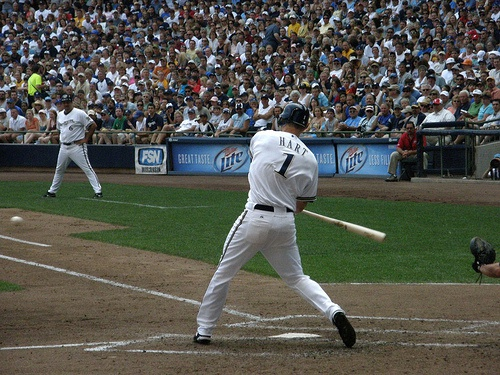Describe the objects in this image and their specific colors. I can see people in gray, black, maroon, and darkgray tones, people in gray, darkgray, lightgray, and black tones, people in gray, darkgray, black, and lavender tones, people in gray, black, and maroon tones, and baseball bat in gray, ivory, darkgreen, and darkgray tones in this image. 